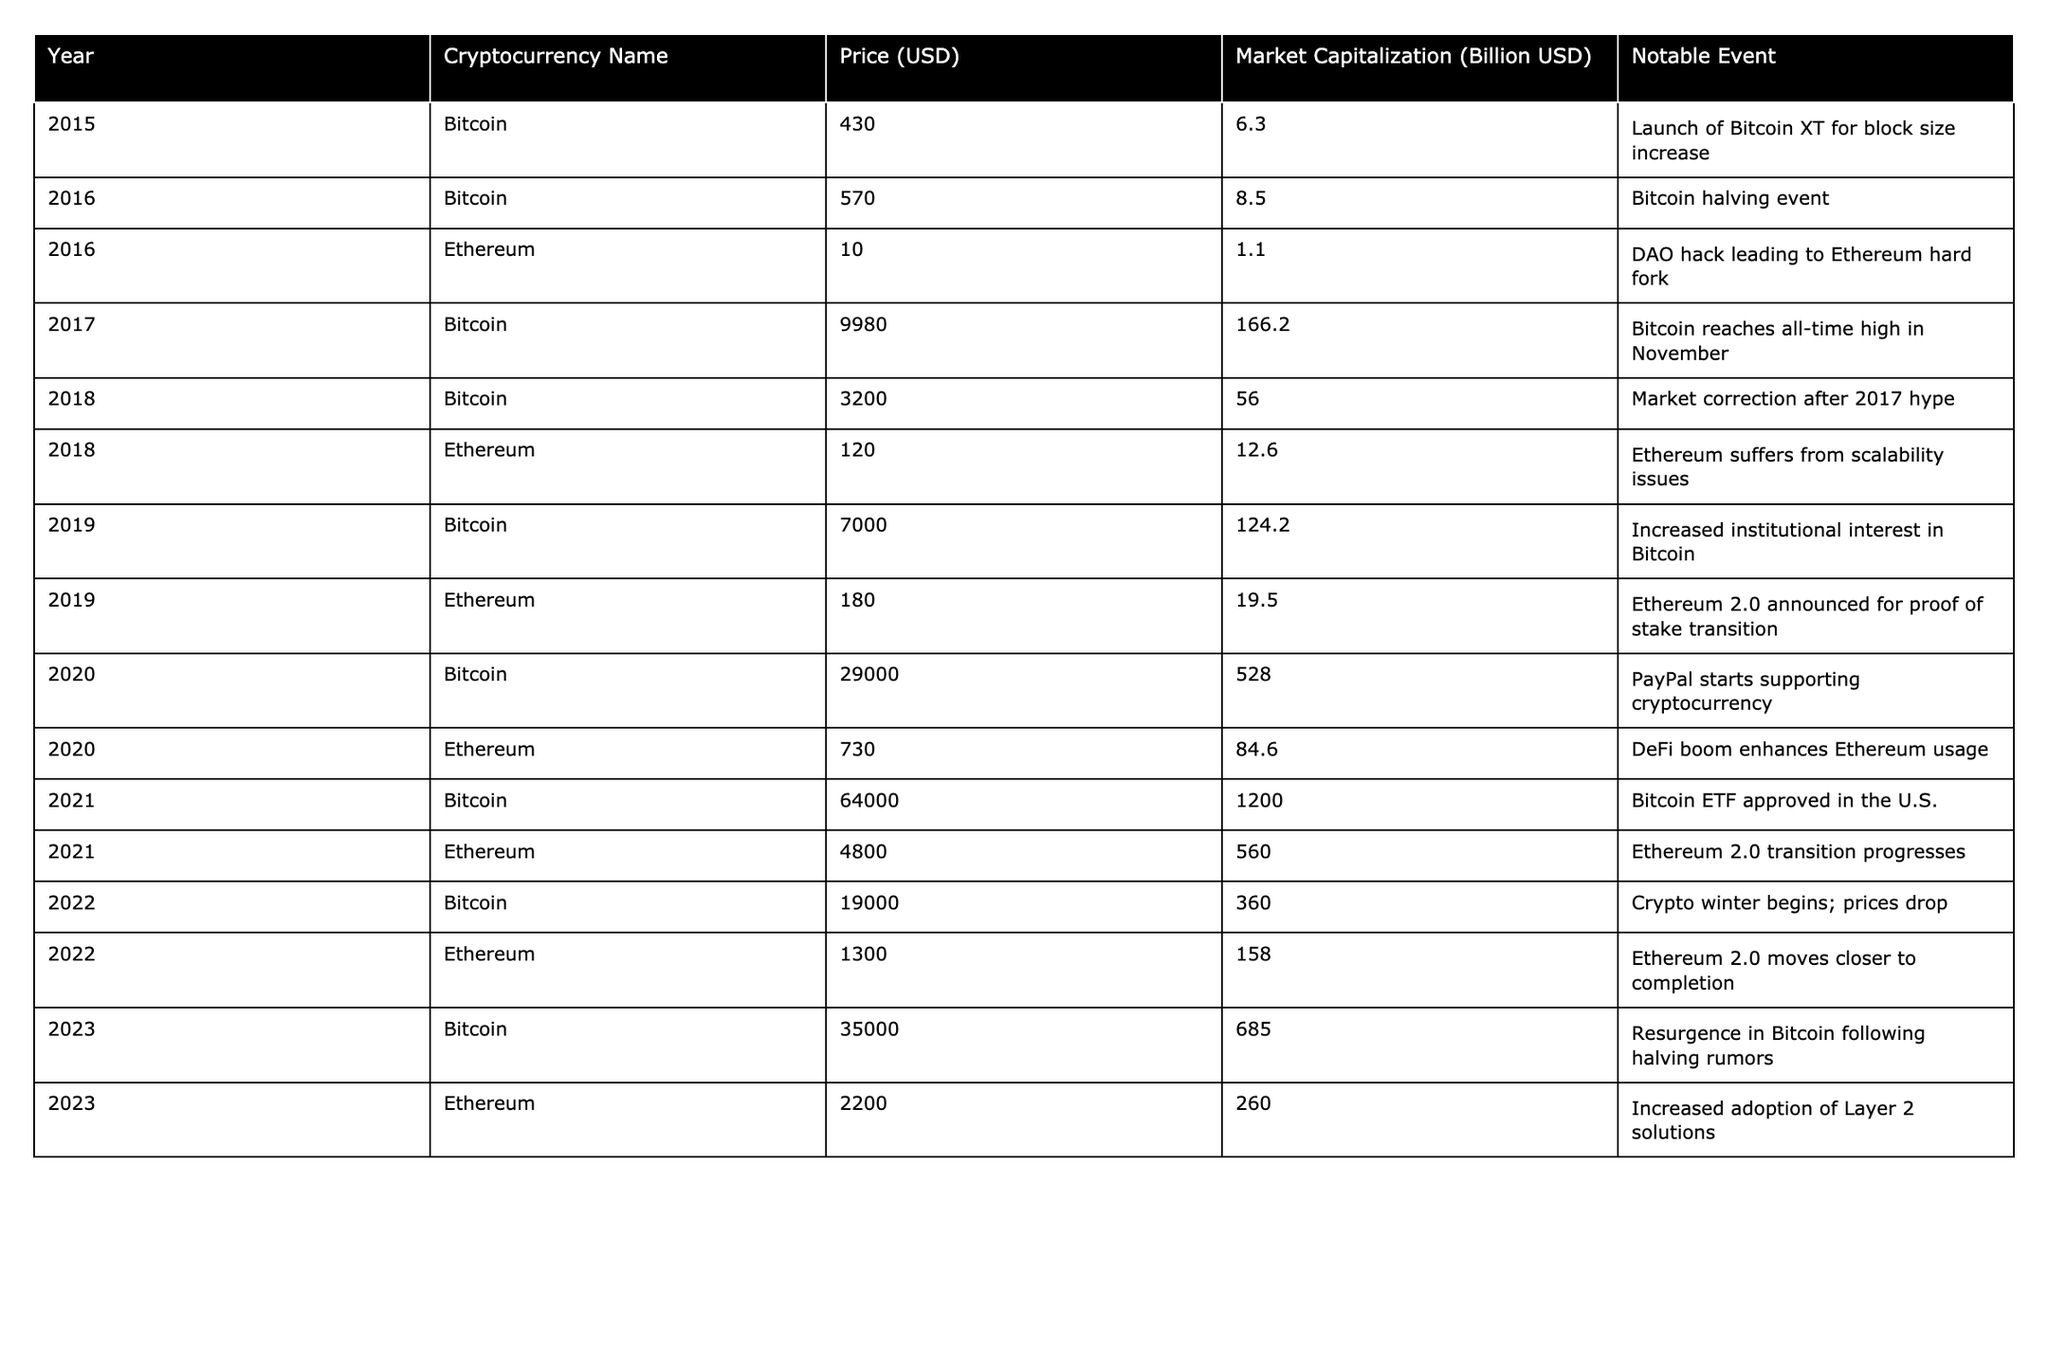What was the price of Bitcoin in 2017? The table shows that in 2017, Bitcoin had a price of 9980.00 USD.
Answer: 9980.00 USD What notable event occurred in 2021 related to Ethereum? According to the table, the notable event for Ethereum in 2021 was the progression of Ethereum 2.0 transition.
Answer: Ethereum 2.0 transition progresses What was the market capitalization of Bitcoin in 2022? The table indicates that in 2022, the market capitalization of Bitcoin was 360.0 billion USD.
Answer: 360.0 billion USD How much did the price of Ethereum change from 2020 to 2022? The price of Ethereum in 2020 was 730.00 USD and in 2022 it was 1300.00 USD. The change is 1300.00 - 730.00 = 570.00 USD.
Answer: 570.00 USD True or False: Bitcoin's price was higher in 2019 than in 2018. The table shows that Bitcoin's price was 7000.00 USD in 2019 and 3200.00 USD in 2018. Since 7000.00 > 3200.00, the statement is True.
Answer: True What was the average price of Bitcoin for the years 2015 to 2021? The prices of Bitcoin from 2015 to 2021 are: 430.00, 570.00, 9980.00, 3200.00, 7000.00, 29000.00, and 64000.00. The sum is 430.00 + 570.00 + 9980.00 + 3200.00 + 7000.00 + 29000.00 + 64000.00 = 113180.00. There are 7 data points, so the average is 113180.00 / 7 ≈ 16168.57.
Answer: ≈ 16168.57 Which cryptocurrency had the highest price increase from 2019 to 2020? Bitcoin had a price of 7000.00 USD in 2019 and 29000.00 USD in 2020, an increase of 22000.00 USD. Ethereum saw an increase from 180.00 USD in 2019 to 730.00 USD in 2020, which is 550.00 USD. Comparing both, Bitcoin's increase is greater.
Answer: Bitcoin In which year did Ethereum first reach a price of over 1000 USD? By examining the table, Ethereum first surpassed 1000 USD in 2021 when its price reached 4800.00 USD.
Answer: 2021 What is the difference between the market capitalization of Bitcoin in 2020 and 2023? The market capitalizations are 528.0 billion USD in 2020 and 685.0 billion USD in 2023. The difference is 685.0 - 528.0 = 157.0 billion USD.
Answer: 157.0 billion USD How many notable events are recorded for Bitcoin from 2015 to 2023? The table lists notable events for Bitcoin in 2015, 2016, 2017, 2018, 2019, 2020, 2021, 2022, and 2023, totaling 9 events.
Answer: 9 events 